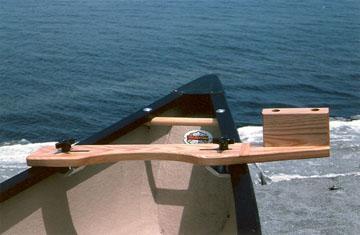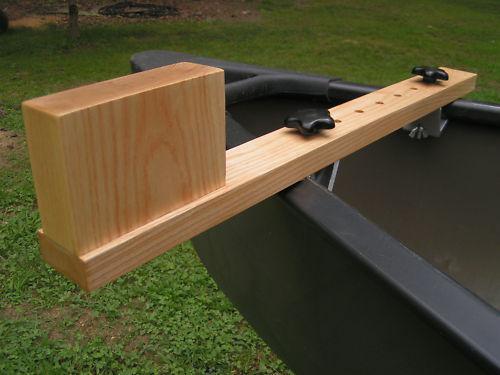The first image is the image on the left, the second image is the image on the right. For the images displayed, is the sentence "An image shows a wooden item attached to an end of a boat, by green ground instead of water." factually correct? Answer yes or no. Yes. The first image is the image on the left, the second image is the image on the right. Evaluate the accuracy of this statement regarding the images: "At least one person is in a green canoe on the water.". Is it true? Answer yes or no. No. 